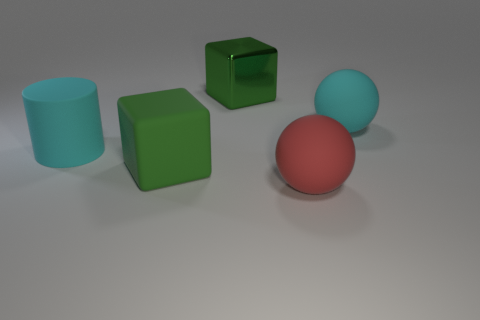There is a big red sphere that is in front of the big rubber cube that is in front of the big metallic thing; what number of big metal cubes are behind it?
Offer a very short reply. 1. There is a big red object; is it the same shape as the big green thing that is behind the big rubber cylinder?
Provide a succinct answer. No. What is the color of the large matte object that is both on the right side of the green metal thing and on the left side of the cyan sphere?
Provide a short and direct response. Red. There is a large cyan object to the right of the large matte ball that is in front of the block in front of the metal object; what is its material?
Offer a terse response. Rubber. Does the rubber block have the same color as the large metallic block?
Your answer should be compact. Yes. What number of other objects are there of the same material as the big cyan ball?
Your answer should be compact. 3. Are there an equal number of big cyan rubber spheres that are right of the large red matte object and blue metallic balls?
Provide a succinct answer. No. There is a large cylinder; what number of big rubber blocks are in front of it?
Provide a short and direct response. 1. What material is the large object that is to the left of the red thing and to the right of the matte cube?
Provide a short and direct response. Metal. What number of big objects are cyan cylinders or cyan things?
Ensure brevity in your answer.  2. 